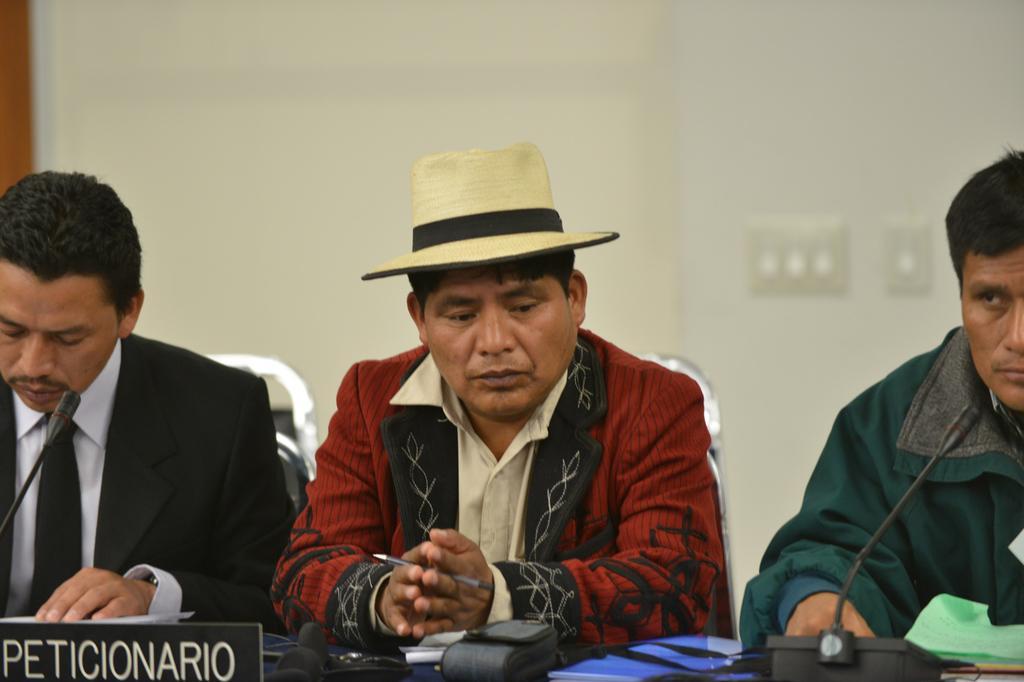How would you summarize this image in a sentence or two? In the picture we can see a three men are sitting on the chairs near the desk, one man is wearing a blazer with a hat and in the background, we can see a wall with a switch, on the desk we can see a microphone. 